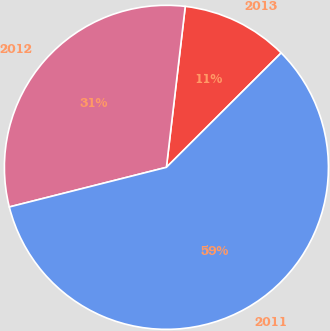<chart> <loc_0><loc_0><loc_500><loc_500><pie_chart><fcel>2013<fcel>2012<fcel>2011<nl><fcel>10.67%<fcel>30.79%<fcel>58.54%<nl></chart> 